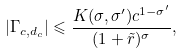<formula> <loc_0><loc_0><loc_500><loc_500>| \Gamma _ { c , d _ { c } } | \leqslant \frac { K ( \sigma , \sigma ^ { \prime } ) c ^ { 1 - \sigma ^ { \prime } } } { ( 1 + \tilde { r } ) ^ { \sigma } } ,</formula> 